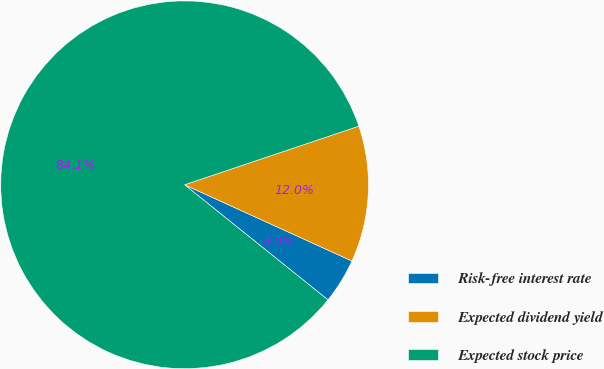<chart> <loc_0><loc_0><loc_500><loc_500><pie_chart><fcel>Risk-free interest rate<fcel>Expected dividend yield<fcel>Expected stock price<nl><fcel>3.96%<fcel>11.97%<fcel>84.07%<nl></chart> 